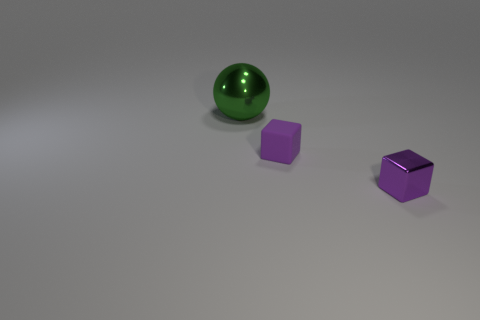Add 1 big cyan metal blocks. How many objects exist? 4 Subtract all spheres. How many objects are left? 2 Add 3 cubes. How many cubes exist? 5 Subtract 0 gray cylinders. How many objects are left? 3 Subtract all small metal blocks. Subtract all green shiny things. How many objects are left? 1 Add 1 tiny objects. How many tiny objects are left? 3 